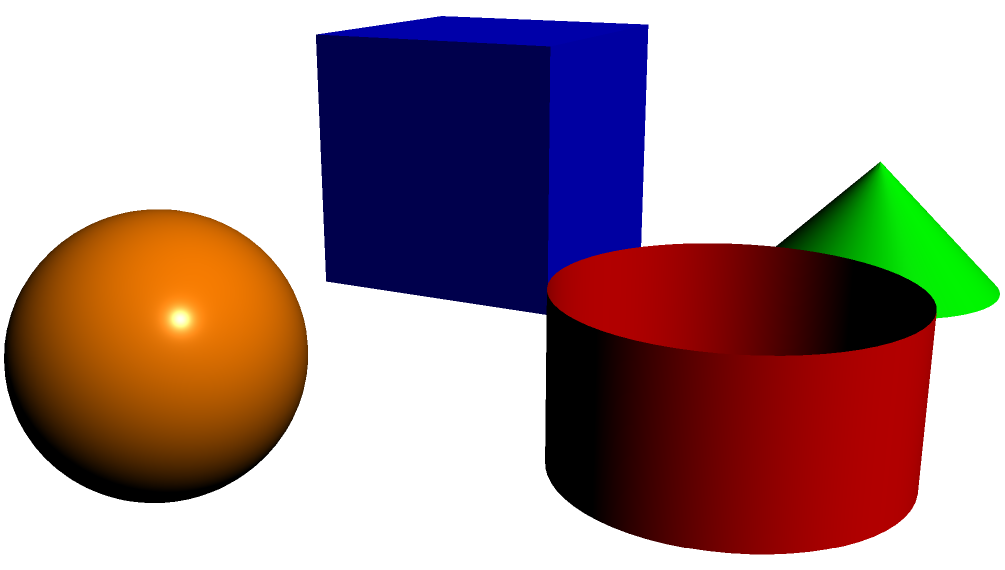In a community project aimed at promoting interfaith understanding, you're tasked with creating an art installation featuring geometric solids representing different faith symbols. The installation includes a blue cube (Christianity), an orange sphere (Buddhism), a green cone (Hinduism), and a red cylinder (Islam). The cube has a side length of 1.5 units, while the other solids have a radius of 0.75 units and a height of 1.5 units. Calculate the total surface area of all four solids combined, rounded to the nearest square unit. Let's calculate the surface area of each solid:

1. Blue Cube (Christianity):
   Surface Area = 6 * side^2
   $$ SA_{cube} = 6 * 1.5^2 = 6 * 2.25 = 13.5 $$

2. Orange Sphere (Buddhism):
   Surface Area = 4 * π * radius^2
   $$ SA_{sphere} = 4 * \pi * 0.75^2 = 4 * \pi * 0.5625 \approx 7.0686 $$

3. Green Cone (Hinduism):
   Surface Area = π * radius * (radius + slant height)
   Slant height = √(radius^2 + height^2) = √(0.75^2 + 1.5^2) ≈ 1.6771
   $$ SA_{cone} = \pi * 0.75 * (0.75 + 1.6771) \approx 5.7250 $$

4. Red Cylinder (Islam):
   Surface Area = 2 * π * radius * (radius + height)
   $$ SA_{cylinder} = 2 * \pi * 0.75 * (0.75 + 1.5) = 2 * \pi * 0.75 * 2.25 \approx 10.6029 $$

Total Surface Area:
$$ SA_{total} = 13.5 + 7.0686 + 5.7250 + 10.6029 = 36.8965 $$

Rounded to the nearest square unit: 37 square units.
Answer: 37 square units 